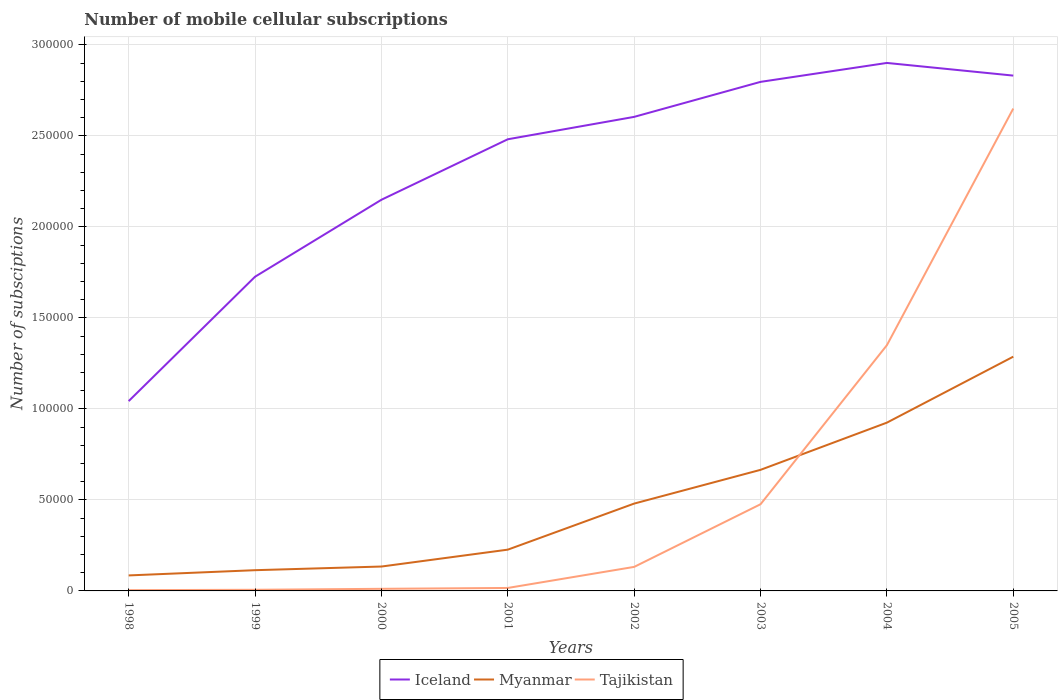How many different coloured lines are there?
Make the answer very short. 3. Does the line corresponding to Myanmar intersect with the line corresponding to Tajikistan?
Your response must be concise. Yes. Across all years, what is the maximum number of mobile cellular subscriptions in Myanmar?
Give a very brief answer. 8516. What is the total number of mobile cellular subscriptions in Iceland in the graph?
Your answer should be very brief. -2.96e+04. What is the difference between the highest and the second highest number of mobile cellular subscriptions in Myanmar?
Ensure brevity in your answer.  1.20e+05. What is the difference between the highest and the lowest number of mobile cellular subscriptions in Tajikistan?
Make the answer very short. 2. Does the graph contain grids?
Ensure brevity in your answer.  Yes. Where does the legend appear in the graph?
Your answer should be very brief. Bottom center. How many legend labels are there?
Provide a succinct answer. 3. What is the title of the graph?
Make the answer very short. Number of mobile cellular subscriptions. What is the label or title of the Y-axis?
Offer a terse response. Number of subsciptions. What is the Number of subsciptions of Iceland in 1998?
Keep it short and to the point. 1.04e+05. What is the Number of subsciptions of Myanmar in 1998?
Make the answer very short. 8516. What is the Number of subsciptions in Tajikistan in 1998?
Your answer should be compact. 420. What is the Number of subsciptions of Iceland in 1999?
Ensure brevity in your answer.  1.73e+05. What is the Number of subsciptions in Myanmar in 1999?
Give a very brief answer. 1.14e+04. What is the Number of subsciptions of Tajikistan in 1999?
Keep it short and to the point. 625. What is the Number of subsciptions of Iceland in 2000?
Your response must be concise. 2.15e+05. What is the Number of subsciptions of Myanmar in 2000?
Ensure brevity in your answer.  1.34e+04. What is the Number of subsciptions of Tajikistan in 2000?
Provide a succinct answer. 1160. What is the Number of subsciptions of Iceland in 2001?
Offer a very short reply. 2.48e+05. What is the Number of subsciptions of Myanmar in 2001?
Ensure brevity in your answer.  2.27e+04. What is the Number of subsciptions of Tajikistan in 2001?
Give a very brief answer. 1630. What is the Number of subsciptions in Iceland in 2002?
Offer a terse response. 2.60e+05. What is the Number of subsciptions of Myanmar in 2002?
Provide a succinct answer. 4.80e+04. What is the Number of subsciptions of Tajikistan in 2002?
Provide a succinct answer. 1.32e+04. What is the Number of subsciptions in Iceland in 2003?
Provide a succinct answer. 2.80e+05. What is the Number of subsciptions of Myanmar in 2003?
Make the answer very short. 6.65e+04. What is the Number of subsciptions of Tajikistan in 2003?
Keep it short and to the point. 4.76e+04. What is the Number of subsciptions of Iceland in 2004?
Offer a very short reply. 2.90e+05. What is the Number of subsciptions of Myanmar in 2004?
Your answer should be compact. 9.25e+04. What is the Number of subsciptions in Tajikistan in 2004?
Offer a terse response. 1.35e+05. What is the Number of subsciptions in Iceland in 2005?
Your answer should be compact. 2.83e+05. What is the Number of subsciptions of Myanmar in 2005?
Provide a succinct answer. 1.29e+05. What is the Number of subsciptions in Tajikistan in 2005?
Ensure brevity in your answer.  2.65e+05. Across all years, what is the maximum Number of subsciptions in Iceland?
Keep it short and to the point. 2.90e+05. Across all years, what is the maximum Number of subsciptions of Myanmar?
Give a very brief answer. 1.29e+05. Across all years, what is the maximum Number of subsciptions in Tajikistan?
Keep it short and to the point. 2.65e+05. Across all years, what is the minimum Number of subsciptions of Iceland?
Offer a terse response. 1.04e+05. Across all years, what is the minimum Number of subsciptions of Myanmar?
Keep it short and to the point. 8516. Across all years, what is the minimum Number of subsciptions of Tajikistan?
Offer a terse response. 420. What is the total Number of subsciptions of Iceland in the graph?
Your answer should be compact. 1.85e+06. What is the total Number of subsciptions in Myanmar in the graph?
Your answer should be very brief. 3.92e+05. What is the total Number of subsciptions in Tajikistan in the graph?
Your answer should be compact. 4.65e+05. What is the difference between the Number of subsciptions of Iceland in 1998 and that in 1999?
Give a very brief answer. -6.83e+04. What is the difference between the Number of subsciptions in Myanmar in 1998 and that in 1999?
Provide a succinct answer. -2873. What is the difference between the Number of subsciptions of Tajikistan in 1998 and that in 1999?
Offer a terse response. -205. What is the difference between the Number of subsciptions in Iceland in 1998 and that in 2000?
Provide a succinct answer. -1.11e+05. What is the difference between the Number of subsciptions of Myanmar in 1998 and that in 2000?
Provide a succinct answer. -4881. What is the difference between the Number of subsciptions in Tajikistan in 1998 and that in 2000?
Ensure brevity in your answer.  -740. What is the difference between the Number of subsciptions in Iceland in 1998 and that in 2001?
Provide a succinct answer. -1.44e+05. What is the difference between the Number of subsciptions in Myanmar in 1998 and that in 2001?
Give a very brief answer. -1.42e+04. What is the difference between the Number of subsciptions in Tajikistan in 1998 and that in 2001?
Keep it short and to the point. -1210. What is the difference between the Number of subsciptions in Iceland in 1998 and that in 2002?
Your response must be concise. -1.56e+05. What is the difference between the Number of subsciptions in Myanmar in 1998 and that in 2002?
Your answer should be compact. -3.95e+04. What is the difference between the Number of subsciptions of Tajikistan in 1998 and that in 2002?
Provide a short and direct response. -1.28e+04. What is the difference between the Number of subsciptions of Iceland in 1998 and that in 2003?
Your answer should be compact. -1.75e+05. What is the difference between the Number of subsciptions of Myanmar in 1998 and that in 2003?
Give a very brief answer. -5.80e+04. What is the difference between the Number of subsciptions in Tajikistan in 1998 and that in 2003?
Make the answer very short. -4.72e+04. What is the difference between the Number of subsciptions in Iceland in 1998 and that in 2004?
Your response must be concise. -1.86e+05. What is the difference between the Number of subsciptions of Myanmar in 1998 and that in 2004?
Your answer should be very brief. -8.39e+04. What is the difference between the Number of subsciptions of Tajikistan in 1998 and that in 2004?
Provide a short and direct response. -1.35e+05. What is the difference between the Number of subsciptions of Iceland in 1998 and that in 2005?
Your answer should be compact. -1.79e+05. What is the difference between the Number of subsciptions of Myanmar in 1998 and that in 2005?
Your answer should be compact. -1.20e+05. What is the difference between the Number of subsciptions of Tajikistan in 1998 and that in 2005?
Offer a terse response. -2.65e+05. What is the difference between the Number of subsciptions in Iceland in 1999 and that in 2000?
Make the answer very short. -4.23e+04. What is the difference between the Number of subsciptions in Myanmar in 1999 and that in 2000?
Your answer should be compact. -2008. What is the difference between the Number of subsciptions in Tajikistan in 1999 and that in 2000?
Offer a terse response. -535. What is the difference between the Number of subsciptions of Iceland in 1999 and that in 2001?
Give a very brief answer. -7.55e+04. What is the difference between the Number of subsciptions in Myanmar in 1999 and that in 2001?
Your response must be concise. -1.13e+04. What is the difference between the Number of subsciptions of Tajikistan in 1999 and that in 2001?
Make the answer very short. -1005. What is the difference between the Number of subsciptions of Iceland in 1999 and that in 2002?
Your answer should be compact. -8.78e+04. What is the difference between the Number of subsciptions in Myanmar in 1999 and that in 2002?
Give a very brief answer. -3.66e+04. What is the difference between the Number of subsciptions in Tajikistan in 1999 and that in 2002?
Your response must be concise. -1.26e+04. What is the difference between the Number of subsciptions of Iceland in 1999 and that in 2003?
Keep it short and to the point. -1.07e+05. What is the difference between the Number of subsciptions in Myanmar in 1999 and that in 2003?
Your answer should be compact. -5.51e+04. What is the difference between the Number of subsciptions of Tajikistan in 1999 and that in 2003?
Your response must be concise. -4.70e+04. What is the difference between the Number of subsciptions of Iceland in 1999 and that in 2004?
Keep it short and to the point. -1.17e+05. What is the difference between the Number of subsciptions in Myanmar in 1999 and that in 2004?
Provide a succinct answer. -8.11e+04. What is the difference between the Number of subsciptions in Tajikistan in 1999 and that in 2004?
Make the answer very short. -1.34e+05. What is the difference between the Number of subsciptions in Iceland in 1999 and that in 2005?
Keep it short and to the point. -1.10e+05. What is the difference between the Number of subsciptions in Myanmar in 1999 and that in 2005?
Offer a very short reply. -1.17e+05. What is the difference between the Number of subsciptions of Tajikistan in 1999 and that in 2005?
Offer a very short reply. -2.64e+05. What is the difference between the Number of subsciptions of Iceland in 2000 and that in 2001?
Provide a short and direct response. -3.32e+04. What is the difference between the Number of subsciptions in Myanmar in 2000 and that in 2001?
Keep it short and to the point. -9274. What is the difference between the Number of subsciptions in Tajikistan in 2000 and that in 2001?
Offer a very short reply. -470. What is the difference between the Number of subsciptions of Iceland in 2000 and that in 2002?
Keep it short and to the point. -4.55e+04. What is the difference between the Number of subsciptions of Myanmar in 2000 and that in 2002?
Offer a terse response. -3.46e+04. What is the difference between the Number of subsciptions of Tajikistan in 2000 and that in 2002?
Offer a very short reply. -1.20e+04. What is the difference between the Number of subsciptions in Iceland in 2000 and that in 2003?
Provide a succinct answer. -6.48e+04. What is the difference between the Number of subsciptions in Myanmar in 2000 and that in 2003?
Provide a short and direct response. -5.31e+04. What is the difference between the Number of subsciptions in Tajikistan in 2000 and that in 2003?
Make the answer very short. -4.65e+04. What is the difference between the Number of subsciptions in Iceland in 2000 and that in 2004?
Keep it short and to the point. -7.52e+04. What is the difference between the Number of subsciptions in Myanmar in 2000 and that in 2004?
Give a very brief answer. -7.91e+04. What is the difference between the Number of subsciptions in Tajikistan in 2000 and that in 2004?
Offer a terse response. -1.34e+05. What is the difference between the Number of subsciptions in Iceland in 2000 and that in 2005?
Give a very brief answer. -6.82e+04. What is the difference between the Number of subsciptions of Myanmar in 2000 and that in 2005?
Offer a very short reply. -1.15e+05. What is the difference between the Number of subsciptions in Tajikistan in 2000 and that in 2005?
Provide a short and direct response. -2.64e+05. What is the difference between the Number of subsciptions of Iceland in 2001 and that in 2002?
Offer a very short reply. -1.23e+04. What is the difference between the Number of subsciptions in Myanmar in 2001 and that in 2002?
Give a very brief answer. -2.53e+04. What is the difference between the Number of subsciptions of Tajikistan in 2001 and that in 2002?
Keep it short and to the point. -1.16e+04. What is the difference between the Number of subsciptions of Iceland in 2001 and that in 2003?
Your answer should be very brief. -3.15e+04. What is the difference between the Number of subsciptions in Myanmar in 2001 and that in 2003?
Your response must be concise. -4.38e+04. What is the difference between the Number of subsciptions in Tajikistan in 2001 and that in 2003?
Your response must be concise. -4.60e+04. What is the difference between the Number of subsciptions of Iceland in 2001 and that in 2004?
Your answer should be very brief. -4.19e+04. What is the difference between the Number of subsciptions in Myanmar in 2001 and that in 2004?
Make the answer very short. -6.98e+04. What is the difference between the Number of subsciptions in Tajikistan in 2001 and that in 2004?
Your answer should be compact. -1.33e+05. What is the difference between the Number of subsciptions in Iceland in 2001 and that in 2005?
Keep it short and to the point. -3.50e+04. What is the difference between the Number of subsciptions in Myanmar in 2001 and that in 2005?
Make the answer very short. -1.06e+05. What is the difference between the Number of subsciptions of Tajikistan in 2001 and that in 2005?
Provide a succinct answer. -2.63e+05. What is the difference between the Number of subsciptions of Iceland in 2002 and that in 2003?
Your response must be concise. -1.92e+04. What is the difference between the Number of subsciptions in Myanmar in 2002 and that in 2003?
Offer a very short reply. -1.85e+04. What is the difference between the Number of subsciptions in Tajikistan in 2002 and that in 2003?
Your answer should be compact. -3.44e+04. What is the difference between the Number of subsciptions of Iceland in 2002 and that in 2004?
Keep it short and to the point. -2.96e+04. What is the difference between the Number of subsciptions of Myanmar in 2002 and that in 2004?
Offer a very short reply. -4.45e+04. What is the difference between the Number of subsciptions of Tajikistan in 2002 and that in 2004?
Keep it short and to the point. -1.22e+05. What is the difference between the Number of subsciptions in Iceland in 2002 and that in 2005?
Give a very brief answer. -2.27e+04. What is the difference between the Number of subsciptions in Myanmar in 2002 and that in 2005?
Offer a very short reply. -8.07e+04. What is the difference between the Number of subsciptions in Tajikistan in 2002 and that in 2005?
Give a very brief answer. -2.52e+05. What is the difference between the Number of subsciptions in Iceland in 2003 and that in 2004?
Keep it short and to the point. -1.04e+04. What is the difference between the Number of subsciptions in Myanmar in 2003 and that in 2004?
Keep it short and to the point. -2.59e+04. What is the difference between the Number of subsciptions of Tajikistan in 2003 and that in 2004?
Keep it short and to the point. -8.74e+04. What is the difference between the Number of subsciptions of Iceland in 2003 and that in 2005?
Make the answer very short. -3438. What is the difference between the Number of subsciptions in Myanmar in 2003 and that in 2005?
Ensure brevity in your answer.  -6.22e+04. What is the difference between the Number of subsciptions of Tajikistan in 2003 and that in 2005?
Your answer should be very brief. -2.17e+05. What is the difference between the Number of subsciptions in Iceland in 2004 and that in 2005?
Offer a very short reply. 6960. What is the difference between the Number of subsciptions of Myanmar in 2004 and that in 2005?
Provide a succinct answer. -3.62e+04. What is the difference between the Number of subsciptions of Tajikistan in 2004 and that in 2005?
Your response must be concise. -1.30e+05. What is the difference between the Number of subsciptions of Iceland in 1998 and the Number of subsciptions of Myanmar in 1999?
Your answer should be compact. 9.29e+04. What is the difference between the Number of subsciptions of Iceland in 1998 and the Number of subsciptions of Tajikistan in 1999?
Give a very brief answer. 1.04e+05. What is the difference between the Number of subsciptions in Myanmar in 1998 and the Number of subsciptions in Tajikistan in 1999?
Offer a very short reply. 7891. What is the difference between the Number of subsciptions of Iceland in 1998 and the Number of subsciptions of Myanmar in 2000?
Ensure brevity in your answer.  9.09e+04. What is the difference between the Number of subsciptions of Iceland in 1998 and the Number of subsciptions of Tajikistan in 2000?
Offer a very short reply. 1.03e+05. What is the difference between the Number of subsciptions of Myanmar in 1998 and the Number of subsciptions of Tajikistan in 2000?
Provide a short and direct response. 7356. What is the difference between the Number of subsciptions in Iceland in 1998 and the Number of subsciptions in Myanmar in 2001?
Your response must be concise. 8.16e+04. What is the difference between the Number of subsciptions in Iceland in 1998 and the Number of subsciptions in Tajikistan in 2001?
Provide a succinct answer. 1.03e+05. What is the difference between the Number of subsciptions in Myanmar in 1998 and the Number of subsciptions in Tajikistan in 2001?
Your answer should be compact. 6886. What is the difference between the Number of subsciptions of Iceland in 1998 and the Number of subsciptions of Myanmar in 2002?
Make the answer very short. 5.63e+04. What is the difference between the Number of subsciptions in Iceland in 1998 and the Number of subsciptions in Tajikistan in 2002?
Ensure brevity in your answer.  9.11e+04. What is the difference between the Number of subsciptions in Myanmar in 1998 and the Number of subsciptions in Tajikistan in 2002?
Your answer should be compact. -4684. What is the difference between the Number of subsciptions of Iceland in 1998 and the Number of subsciptions of Myanmar in 2003?
Provide a succinct answer. 3.78e+04. What is the difference between the Number of subsciptions in Iceland in 1998 and the Number of subsciptions in Tajikistan in 2003?
Keep it short and to the point. 5.67e+04. What is the difference between the Number of subsciptions of Myanmar in 1998 and the Number of subsciptions of Tajikistan in 2003?
Keep it short and to the point. -3.91e+04. What is the difference between the Number of subsciptions in Iceland in 1998 and the Number of subsciptions in Myanmar in 2004?
Your answer should be very brief. 1.18e+04. What is the difference between the Number of subsciptions of Iceland in 1998 and the Number of subsciptions of Tajikistan in 2004?
Provide a short and direct response. -3.07e+04. What is the difference between the Number of subsciptions in Myanmar in 1998 and the Number of subsciptions in Tajikistan in 2004?
Your answer should be compact. -1.26e+05. What is the difference between the Number of subsciptions in Iceland in 1998 and the Number of subsciptions in Myanmar in 2005?
Offer a very short reply. -2.44e+04. What is the difference between the Number of subsciptions in Iceland in 1998 and the Number of subsciptions in Tajikistan in 2005?
Offer a very short reply. -1.61e+05. What is the difference between the Number of subsciptions in Myanmar in 1998 and the Number of subsciptions in Tajikistan in 2005?
Your answer should be very brief. -2.56e+05. What is the difference between the Number of subsciptions of Iceland in 1999 and the Number of subsciptions of Myanmar in 2000?
Keep it short and to the point. 1.59e+05. What is the difference between the Number of subsciptions of Iceland in 1999 and the Number of subsciptions of Tajikistan in 2000?
Your response must be concise. 1.71e+05. What is the difference between the Number of subsciptions of Myanmar in 1999 and the Number of subsciptions of Tajikistan in 2000?
Make the answer very short. 1.02e+04. What is the difference between the Number of subsciptions of Iceland in 1999 and the Number of subsciptions of Myanmar in 2001?
Ensure brevity in your answer.  1.50e+05. What is the difference between the Number of subsciptions in Iceland in 1999 and the Number of subsciptions in Tajikistan in 2001?
Offer a very short reply. 1.71e+05. What is the difference between the Number of subsciptions in Myanmar in 1999 and the Number of subsciptions in Tajikistan in 2001?
Ensure brevity in your answer.  9759. What is the difference between the Number of subsciptions in Iceland in 1999 and the Number of subsciptions in Myanmar in 2002?
Offer a terse response. 1.25e+05. What is the difference between the Number of subsciptions in Iceland in 1999 and the Number of subsciptions in Tajikistan in 2002?
Ensure brevity in your answer.  1.59e+05. What is the difference between the Number of subsciptions in Myanmar in 1999 and the Number of subsciptions in Tajikistan in 2002?
Make the answer very short. -1811. What is the difference between the Number of subsciptions in Iceland in 1999 and the Number of subsciptions in Myanmar in 2003?
Make the answer very short. 1.06e+05. What is the difference between the Number of subsciptions in Iceland in 1999 and the Number of subsciptions in Tajikistan in 2003?
Offer a terse response. 1.25e+05. What is the difference between the Number of subsciptions of Myanmar in 1999 and the Number of subsciptions of Tajikistan in 2003?
Offer a very short reply. -3.62e+04. What is the difference between the Number of subsciptions of Iceland in 1999 and the Number of subsciptions of Myanmar in 2004?
Make the answer very short. 8.02e+04. What is the difference between the Number of subsciptions in Iceland in 1999 and the Number of subsciptions in Tajikistan in 2004?
Offer a terse response. 3.76e+04. What is the difference between the Number of subsciptions in Myanmar in 1999 and the Number of subsciptions in Tajikistan in 2004?
Ensure brevity in your answer.  -1.24e+05. What is the difference between the Number of subsciptions in Iceland in 1999 and the Number of subsciptions in Myanmar in 2005?
Offer a very short reply. 4.39e+04. What is the difference between the Number of subsciptions of Iceland in 1999 and the Number of subsciptions of Tajikistan in 2005?
Your answer should be compact. -9.24e+04. What is the difference between the Number of subsciptions in Myanmar in 1999 and the Number of subsciptions in Tajikistan in 2005?
Keep it short and to the point. -2.54e+05. What is the difference between the Number of subsciptions of Iceland in 2000 and the Number of subsciptions of Myanmar in 2001?
Offer a terse response. 1.92e+05. What is the difference between the Number of subsciptions of Iceland in 2000 and the Number of subsciptions of Tajikistan in 2001?
Make the answer very short. 2.13e+05. What is the difference between the Number of subsciptions of Myanmar in 2000 and the Number of subsciptions of Tajikistan in 2001?
Provide a short and direct response. 1.18e+04. What is the difference between the Number of subsciptions of Iceland in 2000 and the Number of subsciptions of Myanmar in 2002?
Make the answer very short. 1.67e+05. What is the difference between the Number of subsciptions of Iceland in 2000 and the Number of subsciptions of Tajikistan in 2002?
Provide a succinct answer. 2.02e+05. What is the difference between the Number of subsciptions in Myanmar in 2000 and the Number of subsciptions in Tajikistan in 2002?
Provide a short and direct response. 197. What is the difference between the Number of subsciptions in Iceland in 2000 and the Number of subsciptions in Myanmar in 2003?
Your answer should be compact. 1.48e+05. What is the difference between the Number of subsciptions of Iceland in 2000 and the Number of subsciptions of Tajikistan in 2003?
Give a very brief answer. 1.67e+05. What is the difference between the Number of subsciptions in Myanmar in 2000 and the Number of subsciptions in Tajikistan in 2003?
Ensure brevity in your answer.  -3.42e+04. What is the difference between the Number of subsciptions in Iceland in 2000 and the Number of subsciptions in Myanmar in 2004?
Provide a short and direct response. 1.22e+05. What is the difference between the Number of subsciptions of Iceland in 2000 and the Number of subsciptions of Tajikistan in 2004?
Offer a very short reply. 7.99e+04. What is the difference between the Number of subsciptions in Myanmar in 2000 and the Number of subsciptions in Tajikistan in 2004?
Ensure brevity in your answer.  -1.22e+05. What is the difference between the Number of subsciptions in Iceland in 2000 and the Number of subsciptions in Myanmar in 2005?
Offer a very short reply. 8.62e+04. What is the difference between the Number of subsciptions of Iceland in 2000 and the Number of subsciptions of Tajikistan in 2005?
Make the answer very short. -5.01e+04. What is the difference between the Number of subsciptions of Myanmar in 2000 and the Number of subsciptions of Tajikistan in 2005?
Your response must be concise. -2.52e+05. What is the difference between the Number of subsciptions in Iceland in 2001 and the Number of subsciptions in Myanmar in 2002?
Your answer should be very brief. 2.00e+05. What is the difference between the Number of subsciptions of Iceland in 2001 and the Number of subsciptions of Tajikistan in 2002?
Offer a very short reply. 2.35e+05. What is the difference between the Number of subsciptions of Myanmar in 2001 and the Number of subsciptions of Tajikistan in 2002?
Provide a short and direct response. 9471. What is the difference between the Number of subsciptions in Iceland in 2001 and the Number of subsciptions in Myanmar in 2003?
Offer a terse response. 1.82e+05. What is the difference between the Number of subsciptions of Iceland in 2001 and the Number of subsciptions of Tajikistan in 2003?
Provide a succinct answer. 2.01e+05. What is the difference between the Number of subsciptions in Myanmar in 2001 and the Number of subsciptions in Tajikistan in 2003?
Make the answer very short. -2.49e+04. What is the difference between the Number of subsciptions of Iceland in 2001 and the Number of subsciptions of Myanmar in 2004?
Your answer should be compact. 1.56e+05. What is the difference between the Number of subsciptions of Iceland in 2001 and the Number of subsciptions of Tajikistan in 2004?
Provide a succinct answer. 1.13e+05. What is the difference between the Number of subsciptions of Myanmar in 2001 and the Number of subsciptions of Tajikistan in 2004?
Your answer should be compact. -1.12e+05. What is the difference between the Number of subsciptions of Iceland in 2001 and the Number of subsciptions of Myanmar in 2005?
Provide a short and direct response. 1.19e+05. What is the difference between the Number of subsciptions in Iceland in 2001 and the Number of subsciptions in Tajikistan in 2005?
Provide a short and direct response. -1.69e+04. What is the difference between the Number of subsciptions in Myanmar in 2001 and the Number of subsciptions in Tajikistan in 2005?
Ensure brevity in your answer.  -2.42e+05. What is the difference between the Number of subsciptions in Iceland in 2002 and the Number of subsciptions in Myanmar in 2003?
Give a very brief answer. 1.94e+05. What is the difference between the Number of subsciptions of Iceland in 2002 and the Number of subsciptions of Tajikistan in 2003?
Give a very brief answer. 2.13e+05. What is the difference between the Number of subsciptions in Myanmar in 2002 and the Number of subsciptions in Tajikistan in 2003?
Your answer should be compact. 365. What is the difference between the Number of subsciptions in Iceland in 2002 and the Number of subsciptions in Myanmar in 2004?
Provide a short and direct response. 1.68e+05. What is the difference between the Number of subsciptions of Iceland in 2002 and the Number of subsciptions of Tajikistan in 2004?
Offer a very short reply. 1.25e+05. What is the difference between the Number of subsciptions in Myanmar in 2002 and the Number of subsciptions in Tajikistan in 2004?
Provide a succinct answer. -8.70e+04. What is the difference between the Number of subsciptions of Iceland in 2002 and the Number of subsciptions of Myanmar in 2005?
Ensure brevity in your answer.  1.32e+05. What is the difference between the Number of subsciptions in Iceland in 2002 and the Number of subsciptions in Tajikistan in 2005?
Keep it short and to the point. -4562. What is the difference between the Number of subsciptions in Myanmar in 2002 and the Number of subsciptions in Tajikistan in 2005?
Your answer should be compact. -2.17e+05. What is the difference between the Number of subsciptions in Iceland in 2003 and the Number of subsciptions in Myanmar in 2004?
Your answer should be very brief. 1.87e+05. What is the difference between the Number of subsciptions of Iceland in 2003 and the Number of subsciptions of Tajikistan in 2004?
Provide a succinct answer. 1.45e+05. What is the difference between the Number of subsciptions in Myanmar in 2003 and the Number of subsciptions in Tajikistan in 2004?
Provide a short and direct response. -6.85e+04. What is the difference between the Number of subsciptions of Iceland in 2003 and the Number of subsciptions of Myanmar in 2005?
Ensure brevity in your answer.  1.51e+05. What is the difference between the Number of subsciptions in Iceland in 2003 and the Number of subsciptions in Tajikistan in 2005?
Keep it short and to the point. 1.47e+04. What is the difference between the Number of subsciptions in Myanmar in 2003 and the Number of subsciptions in Tajikistan in 2005?
Your answer should be compact. -1.98e+05. What is the difference between the Number of subsciptions in Iceland in 2004 and the Number of subsciptions in Myanmar in 2005?
Offer a terse response. 1.61e+05. What is the difference between the Number of subsciptions in Iceland in 2004 and the Number of subsciptions in Tajikistan in 2005?
Keep it short and to the point. 2.51e+04. What is the difference between the Number of subsciptions of Myanmar in 2004 and the Number of subsciptions of Tajikistan in 2005?
Your response must be concise. -1.73e+05. What is the average Number of subsciptions in Iceland per year?
Provide a short and direct response. 2.32e+05. What is the average Number of subsciptions in Myanmar per year?
Your response must be concise. 4.90e+04. What is the average Number of subsciptions of Tajikistan per year?
Your answer should be very brief. 5.81e+04. In the year 1998, what is the difference between the Number of subsciptions of Iceland and Number of subsciptions of Myanmar?
Make the answer very short. 9.58e+04. In the year 1998, what is the difference between the Number of subsciptions of Iceland and Number of subsciptions of Tajikistan?
Offer a very short reply. 1.04e+05. In the year 1998, what is the difference between the Number of subsciptions in Myanmar and Number of subsciptions in Tajikistan?
Offer a very short reply. 8096. In the year 1999, what is the difference between the Number of subsciptions in Iceland and Number of subsciptions in Myanmar?
Your answer should be very brief. 1.61e+05. In the year 1999, what is the difference between the Number of subsciptions of Iceland and Number of subsciptions of Tajikistan?
Ensure brevity in your answer.  1.72e+05. In the year 1999, what is the difference between the Number of subsciptions of Myanmar and Number of subsciptions of Tajikistan?
Keep it short and to the point. 1.08e+04. In the year 2000, what is the difference between the Number of subsciptions of Iceland and Number of subsciptions of Myanmar?
Keep it short and to the point. 2.01e+05. In the year 2000, what is the difference between the Number of subsciptions in Iceland and Number of subsciptions in Tajikistan?
Your answer should be very brief. 2.14e+05. In the year 2000, what is the difference between the Number of subsciptions of Myanmar and Number of subsciptions of Tajikistan?
Provide a succinct answer. 1.22e+04. In the year 2001, what is the difference between the Number of subsciptions in Iceland and Number of subsciptions in Myanmar?
Provide a short and direct response. 2.25e+05. In the year 2001, what is the difference between the Number of subsciptions of Iceland and Number of subsciptions of Tajikistan?
Offer a terse response. 2.47e+05. In the year 2001, what is the difference between the Number of subsciptions of Myanmar and Number of subsciptions of Tajikistan?
Ensure brevity in your answer.  2.10e+04. In the year 2002, what is the difference between the Number of subsciptions of Iceland and Number of subsciptions of Myanmar?
Ensure brevity in your answer.  2.12e+05. In the year 2002, what is the difference between the Number of subsciptions of Iceland and Number of subsciptions of Tajikistan?
Provide a short and direct response. 2.47e+05. In the year 2002, what is the difference between the Number of subsciptions in Myanmar and Number of subsciptions in Tajikistan?
Make the answer very short. 3.48e+04. In the year 2003, what is the difference between the Number of subsciptions of Iceland and Number of subsciptions of Myanmar?
Keep it short and to the point. 2.13e+05. In the year 2003, what is the difference between the Number of subsciptions of Iceland and Number of subsciptions of Tajikistan?
Provide a succinct answer. 2.32e+05. In the year 2003, what is the difference between the Number of subsciptions of Myanmar and Number of subsciptions of Tajikistan?
Offer a terse response. 1.89e+04. In the year 2004, what is the difference between the Number of subsciptions of Iceland and Number of subsciptions of Myanmar?
Make the answer very short. 1.98e+05. In the year 2004, what is the difference between the Number of subsciptions of Iceland and Number of subsciptions of Tajikistan?
Provide a short and direct response. 1.55e+05. In the year 2004, what is the difference between the Number of subsciptions in Myanmar and Number of subsciptions in Tajikistan?
Ensure brevity in your answer.  -4.25e+04. In the year 2005, what is the difference between the Number of subsciptions in Iceland and Number of subsciptions in Myanmar?
Make the answer very short. 1.54e+05. In the year 2005, what is the difference between the Number of subsciptions of Iceland and Number of subsciptions of Tajikistan?
Ensure brevity in your answer.  1.81e+04. In the year 2005, what is the difference between the Number of subsciptions in Myanmar and Number of subsciptions in Tajikistan?
Your answer should be compact. -1.36e+05. What is the ratio of the Number of subsciptions of Iceland in 1998 to that in 1999?
Your response must be concise. 0.6. What is the ratio of the Number of subsciptions of Myanmar in 1998 to that in 1999?
Your response must be concise. 0.75. What is the ratio of the Number of subsciptions in Tajikistan in 1998 to that in 1999?
Offer a very short reply. 0.67. What is the ratio of the Number of subsciptions of Iceland in 1998 to that in 2000?
Provide a succinct answer. 0.49. What is the ratio of the Number of subsciptions in Myanmar in 1998 to that in 2000?
Your answer should be very brief. 0.64. What is the ratio of the Number of subsciptions of Tajikistan in 1998 to that in 2000?
Offer a terse response. 0.36. What is the ratio of the Number of subsciptions of Iceland in 1998 to that in 2001?
Provide a succinct answer. 0.42. What is the ratio of the Number of subsciptions of Myanmar in 1998 to that in 2001?
Your answer should be compact. 0.38. What is the ratio of the Number of subsciptions in Tajikistan in 1998 to that in 2001?
Keep it short and to the point. 0.26. What is the ratio of the Number of subsciptions of Iceland in 1998 to that in 2002?
Offer a very short reply. 0.4. What is the ratio of the Number of subsciptions in Myanmar in 1998 to that in 2002?
Keep it short and to the point. 0.18. What is the ratio of the Number of subsciptions in Tajikistan in 1998 to that in 2002?
Give a very brief answer. 0.03. What is the ratio of the Number of subsciptions in Iceland in 1998 to that in 2003?
Your answer should be compact. 0.37. What is the ratio of the Number of subsciptions of Myanmar in 1998 to that in 2003?
Provide a succinct answer. 0.13. What is the ratio of the Number of subsciptions of Tajikistan in 1998 to that in 2003?
Your answer should be compact. 0.01. What is the ratio of the Number of subsciptions in Iceland in 1998 to that in 2004?
Provide a short and direct response. 0.36. What is the ratio of the Number of subsciptions in Myanmar in 1998 to that in 2004?
Provide a short and direct response. 0.09. What is the ratio of the Number of subsciptions in Tajikistan in 1998 to that in 2004?
Ensure brevity in your answer.  0. What is the ratio of the Number of subsciptions in Iceland in 1998 to that in 2005?
Your response must be concise. 0.37. What is the ratio of the Number of subsciptions of Myanmar in 1998 to that in 2005?
Keep it short and to the point. 0.07. What is the ratio of the Number of subsciptions of Tajikistan in 1998 to that in 2005?
Ensure brevity in your answer.  0. What is the ratio of the Number of subsciptions in Iceland in 1999 to that in 2000?
Offer a very short reply. 0.8. What is the ratio of the Number of subsciptions in Myanmar in 1999 to that in 2000?
Offer a very short reply. 0.85. What is the ratio of the Number of subsciptions in Tajikistan in 1999 to that in 2000?
Keep it short and to the point. 0.54. What is the ratio of the Number of subsciptions of Iceland in 1999 to that in 2001?
Keep it short and to the point. 0.7. What is the ratio of the Number of subsciptions in Myanmar in 1999 to that in 2001?
Offer a terse response. 0.5. What is the ratio of the Number of subsciptions in Tajikistan in 1999 to that in 2001?
Your response must be concise. 0.38. What is the ratio of the Number of subsciptions of Iceland in 1999 to that in 2002?
Offer a terse response. 0.66. What is the ratio of the Number of subsciptions of Myanmar in 1999 to that in 2002?
Give a very brief answer. 0.24. What is the ratio of the Number of subsciptions in Tajikistan in 1999 to that in 2002?
Give a very brief answer. 0.05. What is the ratio of the Number of subsciptions of Iceland in 1999 to that in 2003?
Provide a succinct answer. 0.62. What is the ratio of the Number of subsciptions of Myanmar in 1999 to that in 2003?
Give a very brief answer. 0.17. What is the ratio of the Number of subsciptions in Tajikistan in 1999 to that in 2003?
Ensure brevity in your answer.  0.01. What is the ratio of the Number of subsciptions of Iceland in 1999 to that in 2004?
Give a very brief answer. 0.6. What is the ratio of the Number of subsciptions of Myanmar in 1999 to that in 2004?
Keep it short and to the point. 0.12. What is the ratio of the Number of subsciptions of Tajikistan in 1999 to that in 2004?
Ensure brevity in your answer.  0. What is the ratio of the Number of subsciptions in Iceland in 1999 to that in 2005?
Make the answer very short. 0.61. What is the ratio of the Number of subsciptions of Myanmar in 1999 to that in 2005?
Your answer should be compact. 0.09. What is the ratio of the Number of subsciptions in Tajikistan in 1999 to that in 2005?
Give a very brief answer. 0. What is the ratio of the Number of subsciptions in Iceland in 2000 to that in 2001?
Your response must be concise. 0.87. What is the ratio of the Number of subsciptions in Myanmar in 2000 to that in 2001?
Your response must be concise. 0.59. What is the ratio of the Number of subsciptions in Tajikistan in 2000 to that in 2001?
Keep it short and to the point. 0.71. What is the ratio of the Number of subsciptions in Iceland in 2000 to that in 2002?
Your response must be concise. 0.83. What is the ratio of the Number of subsciptions of Myanmar in 2000 to that in 2002?
Offer a very short reply. 0.28. What is the ratio of the Number of subsciptions in Tajikistan in 2000 to that in 2002?
Give a very brief answer. 0.09. What is the ratio of the Number of subsciptions of Iceland in 2000 to that in 2003?
Make the answer very short. 0.77. What is the ratio of the Number of subsciptions in Myanmar in 2000 to that in 2003?
Offer a very short reply. 0.2. What is the ratio of the Number of subsciptions of Tajikistan in 2000 to that in 2003?
Your answer should be very brief. 0.02. What is the ratio of the Number of subsciptions in Iceland in 2000 to that in 2004?
Provide a succinct answer. 0.74. What is the ratio of the Number of subsciptions of Myanmar in 2000 to that in 2004?
Offer a terse response. 0.14. What is the ratio of the Number of subsciptions of Tajikistan in 2000 to that in 2004?
Offer a terse response. 0.01. What is the ratio of the Number of subsciptions in Iceland in 2000 to that in 2005?
Make the answer very short. 0.76. What is the ratio of the Number of subsciptions in Myanmar in 2000 to that in 2005?
Offer a very short reply. 0.1. What is the ratio of the Number of subsciptions of Tajikistan in 2000 to that in 2005?
Offer a very short reply. 0. What is the ratio of the Number of subsciptions of Iceland in 2001 to that in 2002?
Your response must be concise. 0.95. What is the ratio of the Number of subsciptions in Myanmar in 2001 to that in 2002?
Your answer should be very brief. 0.47. What is the ratio of the Number of subsciptions in Tajikistan in 2001 to that in 2002?
Make the answer very short. 0.12. What is the ratio of the Number of subsciptions in Iceland in 2001 to that in 2003?
Offer a very short reply. 0.89. What is the ratio of the Number of subsciptions in Myanmar in 2001 to that in 2003?
Provide a short and direct response. 0.34. What is the ratio of the Number of subsciptions of Tajikistan in 2001 to that in 2003?
Make the answer very short. 0.03. What is the ratio of the Number of subsciptions of Iceland in 2001 to that in 2004?
Your answer should be very brief. 0.86. What is the ratio of the Number of subsciptions of Myanmar in 2001 to that in 2004?
Offer a terse response. 0.25. What is the ratio of the Number of subsciptions in Tajikistan in 2001 to that in 2004?
Keep it short and to the point. 0.01. What is the ratio of the Number of subsciptions of Iceland in 2001 to that in 2005?
Your answer should be compact. 0.88. What is the ratio of the Number of subsciptions in Myanmar in 2001 to that in 2005?
Provide a short and direct response. 0.18. What is the ratio of the Number of subsciptions of Tajikistan in 2001 to that in 2005?
Your answer should be very brief. 0.01. What is the ratio of the Number of subsciptions in Iceland in 2002 to that in 2003?
Your answer should be compact. 0.93. What is the ratio of the Number of subsciptions in Myanmar in 2002 to that in 2003?
Your answer should be compact. 0.72. What is the ratio of the Number of subsciptions in Tajikistan in 2002 to that in 2003?
Make the answer very short. 0.28. What is the ratio of the Number of subsciptions of Iceland in 2002 to that in 2004?
Offer a very short reply. 0.9. What is the ratio of the Number of subsciptions of Myanmar in 2002 to that in 2004?
Ensure brevity in your answer.  0.52. What is the ratio of the Number of subsciptions of Tajikistan in 2002 to that in 2004?
Your answer should be very brief. 0.1. What is the ratio of the Number of subsciptions of Iceland in 2002 to that in 2005?
Offer a very short reply. 0.92. What is the ratio of the Number of subsciptions in Myanmar in 2002 to that in 2005?
Your answer should be very brief. 0.37. What is the ratio of the Number of subsciptions in Tajikistan in 2002 to that in 2005?
Your response must be concise. 0.05. What is the ratio of the Number of subsciptions of Iceland in 2003 to that in 2004?
Provide a short and direct response. 0.96. What is the ratio of the Number of subsciptions of Myanmar in 2003 to that in 2004?
Offer a terse response. 0.72. What is the ratio of the Number of subsciptions in Tajikistan in 2003 to that in 2004?
Offer a terse response. 0.35. What is the ratio of the Number of subsciptions in Iceland in 2003 to that in 2005?
Offer a very short reply. 0.99. What is the ratio of the Number of subsciptions in Myanmar in 2003 to that in 2005?
Provide a short and direct response. 0.52. What is the ratio of the Number of subsciptions in Tajikistan in 2003 to that in 2005?
Ensure brevity in your answer.  0.18. What is the ratio of the Number of subsciptions in Iceland in 2004 to that in 2005?
Give a very brief answer. 1.02. What is the ratio of the Number of subsciptions of Myanmar in 2004 to that in 2005?
Keep it short and to the point. 0.72. What is the ratio of the Number of subsciptions of Tajikistan in 2004 to that in 2005?
Keep it short and to the point. 0.51. What is the difference between the highest and the second highest Number of subsciptions of Iceland?
Your answer should be compact. 6960. What is the difference between the highest and the second highest Number of subsciptions of Myanmar?
Offer a very short reply. 3.62e+04. What is the difference between the highest and the second highest Number of subsciptions in Tajikistan?
Offer a very short reply. 1.30e+05. What is the difference between the highest and the lowest Number of subsciptions of Iceland?
Offer a very short reply. 1.86e+05. What is the difference between the highest and the lowest Number of subsciptions in Myanmar?
Your answer should be very brief. 1.20e+05. What is the difference between the highest and the lowest Number of subsciptions in Tajikistan?
Your response must be concise. 2.65e+05. 